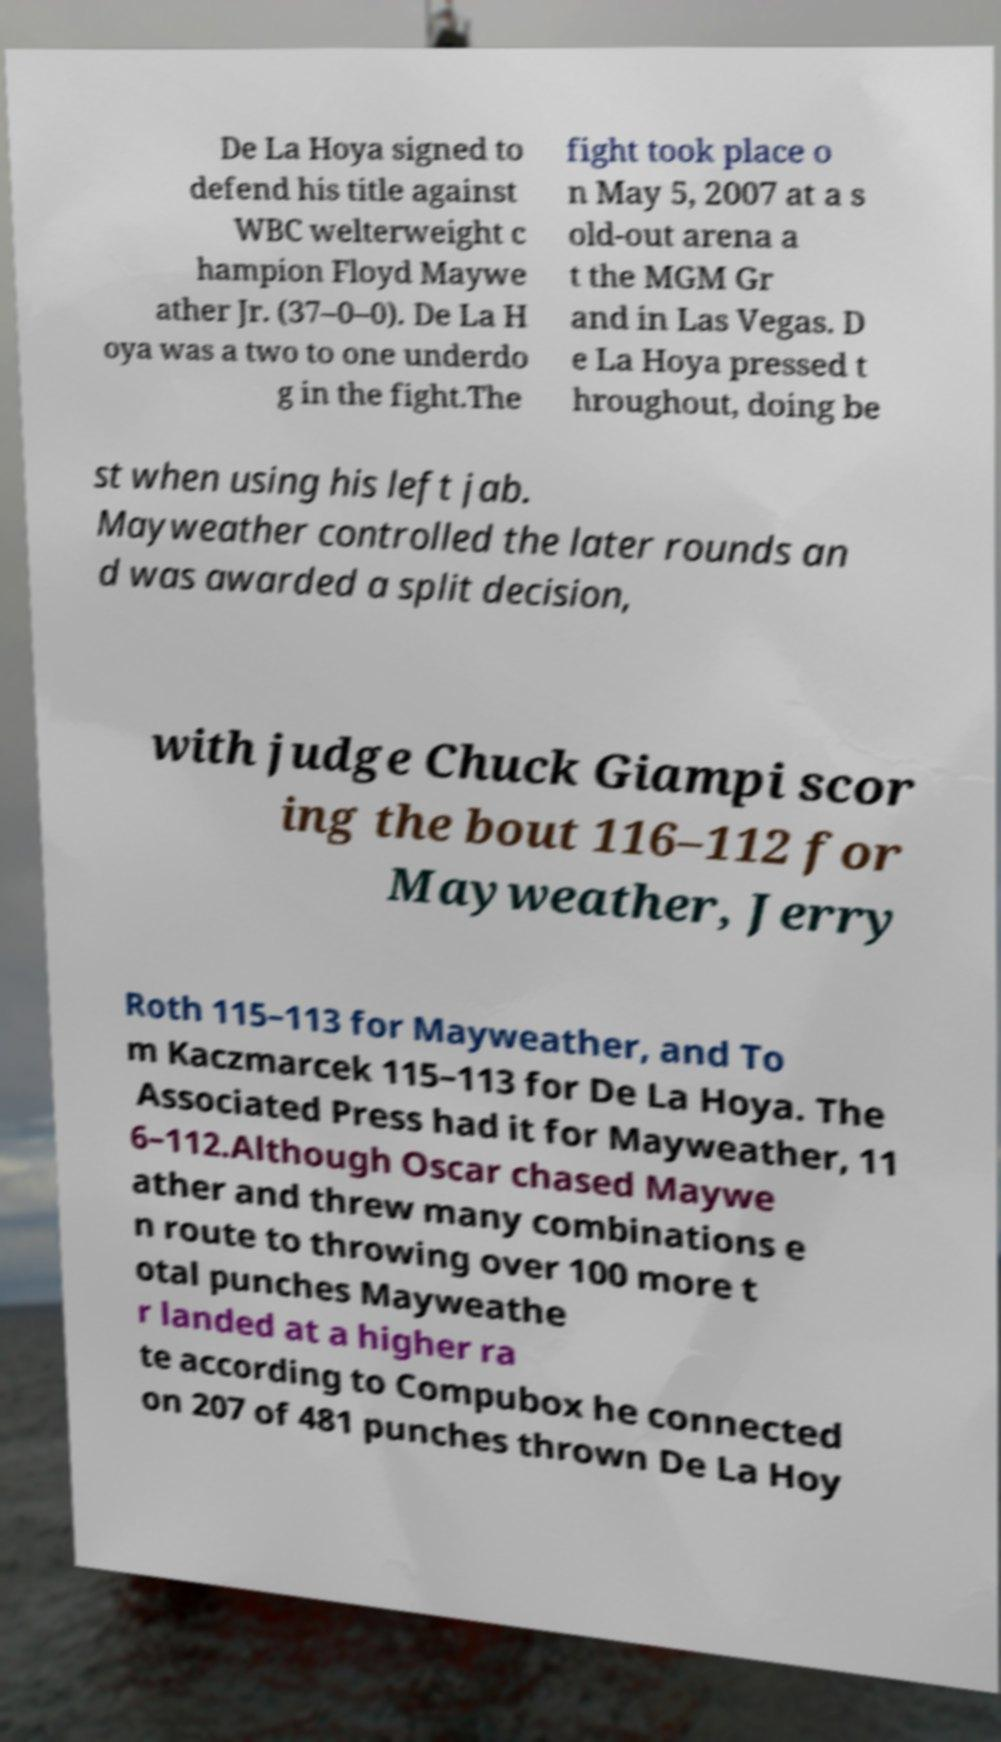Please identify and transcribe the text found in this image. De La Hoya signed to defend his title against WBC welterweight c hampion Floyd Maywe ather Jr. (37–0–0). De La H oya was a two to one underdo g in the fight.The fight took place o n May 5, 2007 at a s old-out arena a t the MGM Gr and in Las Vegas. D e La Hoya pressed t hroughout, doing be st when using his left jab. Mayweather controlled the later rounds an d was awarded a split decision, with judge Chuck Giampi scor ing the bout 116–112 for Mayweather, Jerry Roth 115–113 for Mayweather, and To m Kaczmarcek 115–113 for De La Hoya. The Associated Press had it for Mayweather, 11 6–112.Although Oscar chased Maywe ather and threw many combinations e n route to throwing over 100 more t otal punches Mayweathe r landed at a higher ra te according to Compubox he connected on 207 of 481 punches thrown De La Hoy 